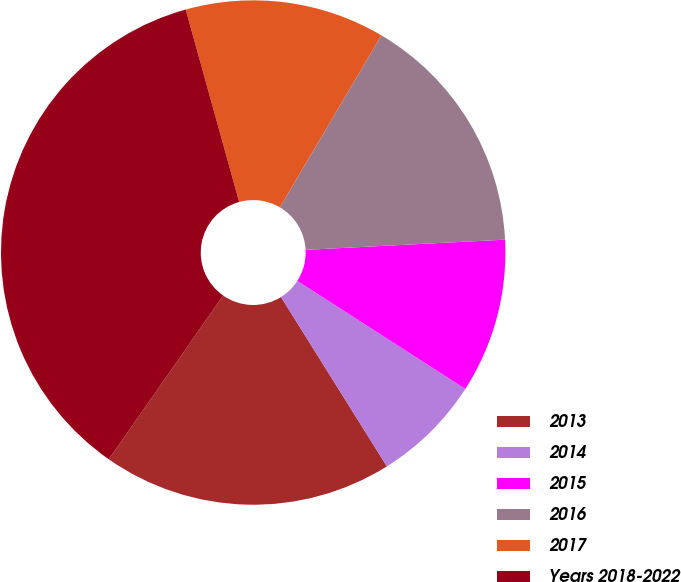<chart> <loc_0><loc_0><loc_500><loc_500><pie_chart><fcel>2013<fcel>2014<fcel>2015<fcel>2016<fcel>2017<fcel>Years 2018-2022<nl><fcel>18.6%<fcel>7.01%<fcel>9.91%<fcel>15.7%<fcel>12.8%<fcel>35.98%<nl></chart> 